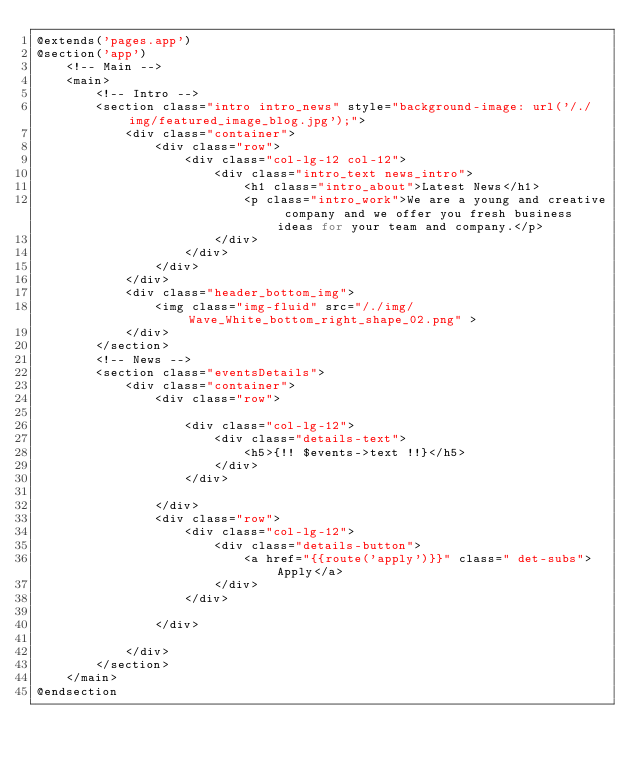<code> <loc_0><loc_0><loc_500><loc_500><_PHP_>@extends('pages.app')
@section('app')
    <!-- Main -->
    <main>
        <!-- Intro -->
        <section class="intro intro_news" style="background-image: url('/./img/featured_image_blog.jpg');">
            <div class="container">
                <div class="row">
                    <div class="col-lg-12 col-12">
                        <div class="intro_text news_intro">
                            <h1 class="intro_about">Latest News</h1>
                            <p class="intro_work">We are a young and creative company and we offer you fresh business ideas for your team and company.</p>
                        </div>
                    </div>
                </div>
            </div>
            <div class="header_bottom_img">
                <img class="img-fluid" src="/./img/Wave_White_bottom_right_shape_02.png" >
            </div>
        </section>
        <!-- News -->
        <section class="eventsDetails">
            <div class="container">
                <div class="row">

                    <div class="col-lg-12">
                        <div class="details-text">
                            <h5>{!! $events->text !!}</h5>
                        </div>
                    </div>

                </div>
                <div class="row">
                    <div class="col-lg-12">
                        <div class="details-button">
                            <a href="{{route('apply')}}" class=" det-subs">Apply</a>
                        </div>
                    </div>

                </div>

            </div>
        </section>
    </main>
@endsection
</code> 